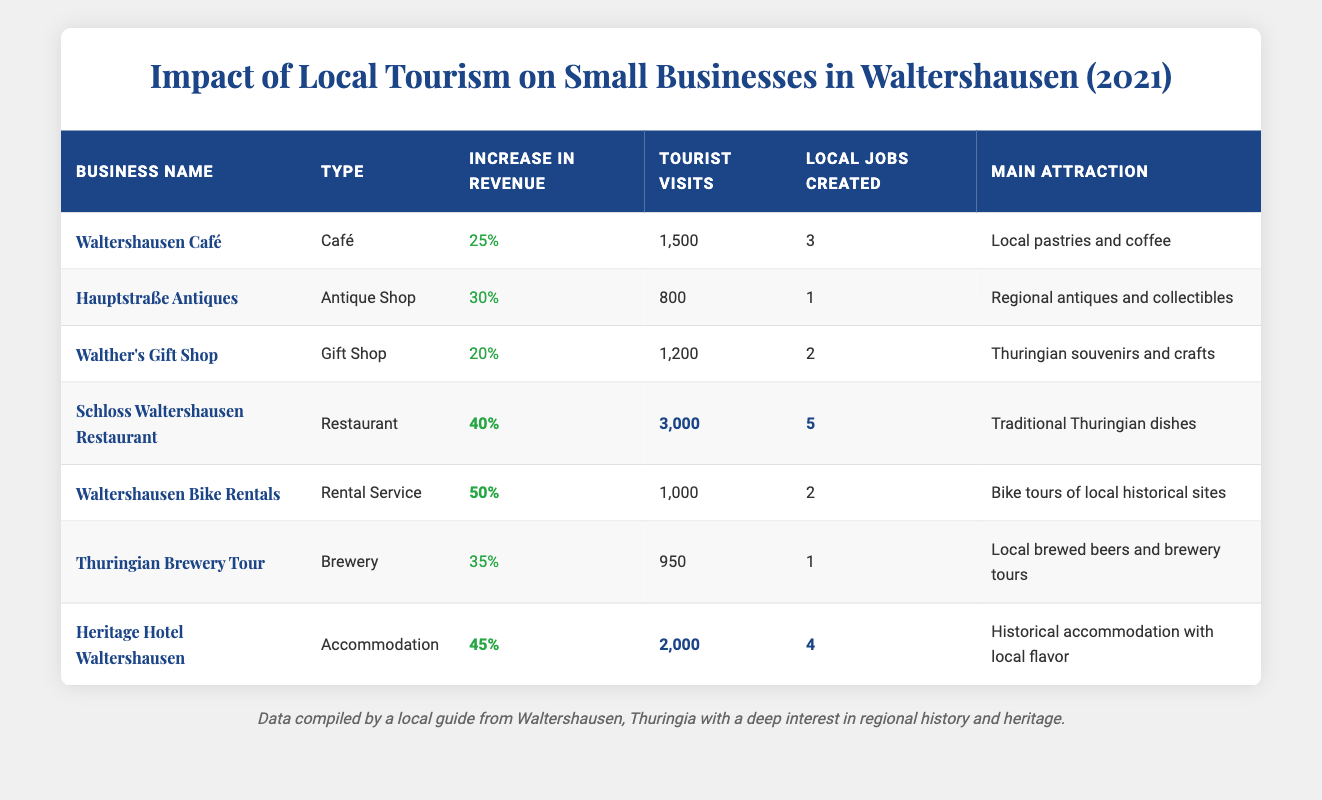What is the increase in revenue for Schloss Waltershausen Restaurant? According to the table, the increase in revenue for Schloss Waltershausen Restaurant is stated directly as 40%.
Answer: 40% How many tourist visits did Waltershausen Bike Rentals receive? The table specifies that Waltershausen Bike Rentals received 1,000 tourist visits.
Answer: 1,000 Which business type saw the highest percentage increase in revenue? By comparing the percentages in the table, Waltershausen Bike Rentals had the highest increase in revenue at 50%.
Answer: Rental Service How many local jobs were created by the Heritage Hotel Waltershausen? The table lists that the Heritage Hotel Waltershausen created 4 local jobs.
Answer: 4 What is the total number of tourist visits for all the businesses combined? We sum the tourist visits: 1,500 + 800 + 1,200 + 3,000 + 1,000 + 950 + 2,000 = 10,450.
Answer: 10,450 Did Hauptstraße Antiques create more local jobs than Walther's Gift Shop? Hauptstraße Antiques created 1 job, while Walther's Gift Shop created 2 jobs. Therefore, the statement is false.
Answer: No What percentage of the total tourist visits did Schloss Waltershausen Restaurant attract? First, we find the total tourist visits (10,450), then calculate Schloss Waltershausen Restaurant's share: (3,000 / 10,450) * 100 ≈ 28.7%.
Answer: Approximately 28.7% Which business had a greater increase in revenue, Walther's Gift Shop or Hauptstraße Antiques? Walther's Gift Shop had a 20% increase, while Hauptstraße Antiques had a 30% increase, indicating Hauptstraße Antiques had a greater increase.
Answer: Hauptstraße Antiques How many local jobs were created in total by the businesses listed? Adding up the local jobs created: 3 + 1 + 2 + 5 + 2 + 1 + 4 = 18. Thus, the total is 18 local jobs.
Answer: 18 Which business attracted fewer than 1,000 tourist visits? Hauptstraße Antiques, which attracted 800 tourist visits, is the only business that fits this criterion.
Answer: Hauptstraße Antiques What is the average increase in revenue among all businesses listed? The percentage increases are 25%, 30%, 20%, 40%, 50%, 35%, and 45%. The average is calculated as (25 + 30 + 20 + 40 + 50 + 35 + 45) / 7 = 36.43%.
Answer: Approximately 36.43% 